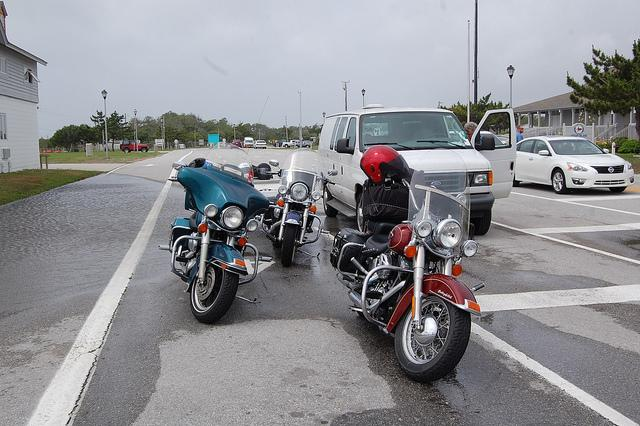Where are these vehicles located?

Choices:
A) parking lot
B) garage
C) highway
D) driveway parking lot 